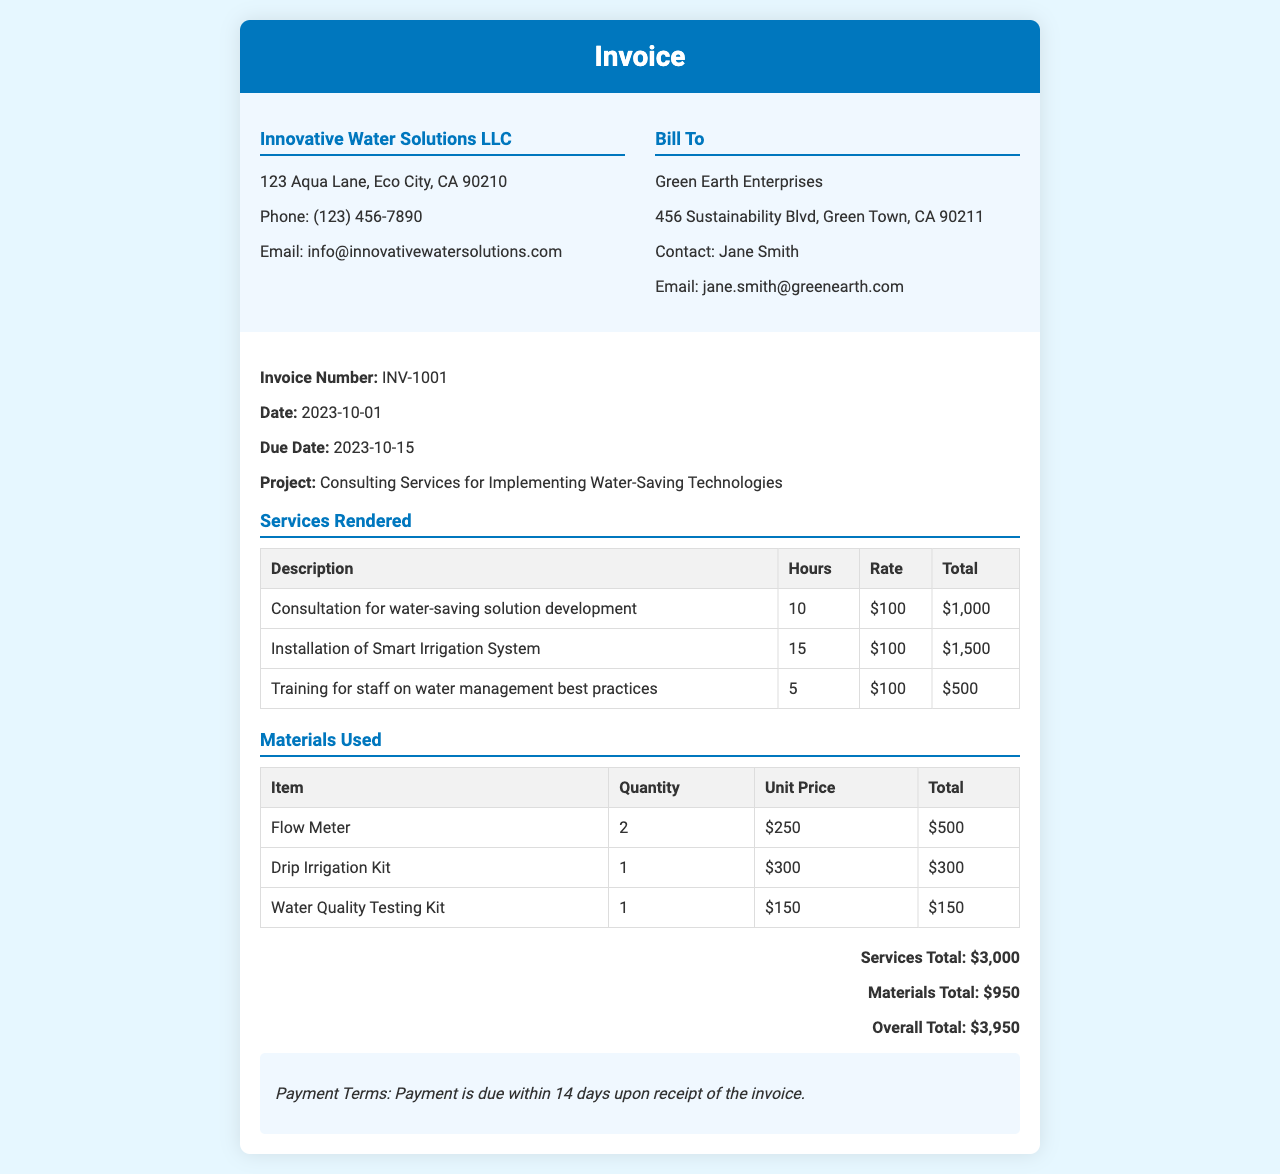What is the invoice number? The invoice number is indicated under the invoice details section of the document.
Answer: INV-1001 What is the due date for payment? The due date is listed in the invoice details section.
Answer: 2023-10-15 How many hours were spent on the installation of the Smart Irrigation System? The number of hours is specified in the table for services rendered.
Answer: 15 What is the total amount for materials used? The total amount for materials is calculated in the invoice body section.
Answer: $950 Who is the client for this invoice? The client information can be found in the invoice details section.
Answer: Green Earth Enterprises What is the total amount for services rendered? The services total is summed from the services rendered table in the document.
Answer: $3,000 What is the overall total for the invoice? The overall total combines both services and materials total, as shown in the total section.
Answer: $3,950 What is the payment term specified in the invoice? The payment terms are mentioned at the end of the invoice body.
Answer: Payment is due within 14 days upon receipt of the invoice How many Flow Meters were used? The quantity of Flow Meters is listed in the materials used table.
Answer: 2 